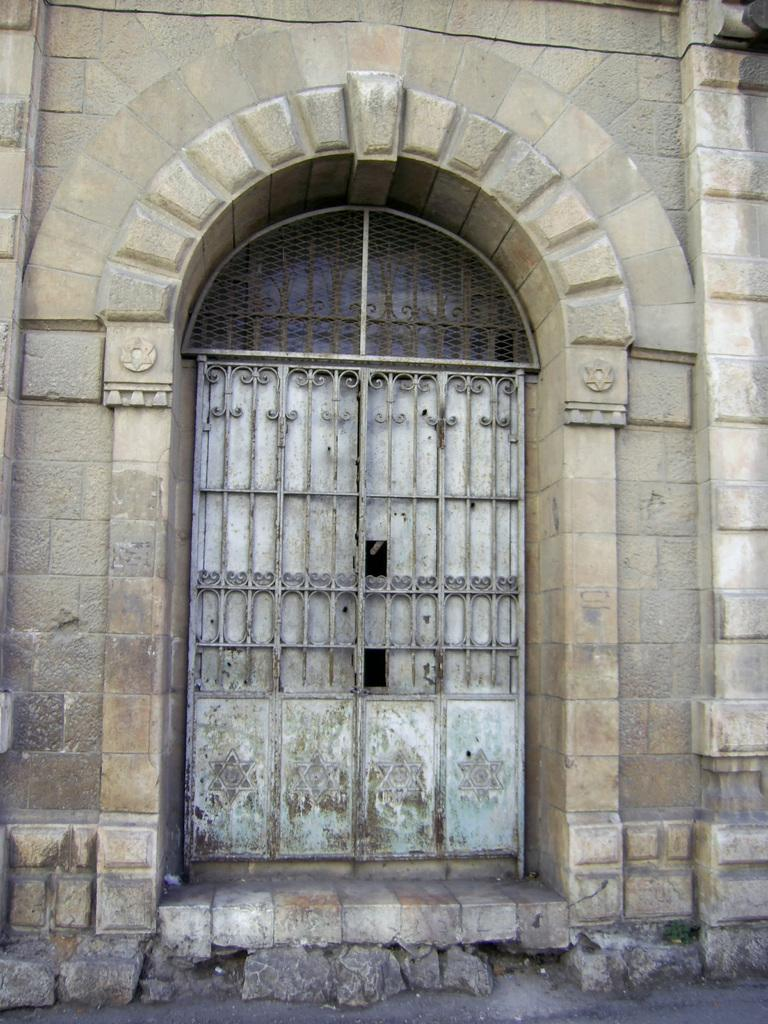What is the main subject in the center of the image? There is a building in the center of the image. What feature of the building is mentioned in the facts? The building has a door. What type of natural formation is visible at the bottom of the image? There are rocks at the bottom of the image. Where is the harbor located in the image? There is no harbor present in the image. Can you tell me how many drawers are visible in the image? There are no drawers present in the image. 